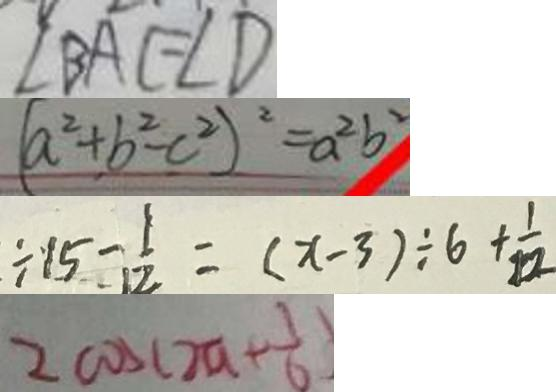Convert formula to latex. <formula><loc_0><loc_0><loc_500><loc_500>\angle B A C = \angle D 
 ( a ^ { 2 } + b ^ { 2 } - c ^ { 2 } ) ^ { 2 } = a ^ { 2 } b ^ { 2 } 
 \div 1 5 - \frac { 1 } { 1 2 } = ( x - 3 ) \div 6 + \frac { 1 } { 1 2 } 
 2 \cos ( 2 a + \frac { 1 } { 6 } )</formula> 